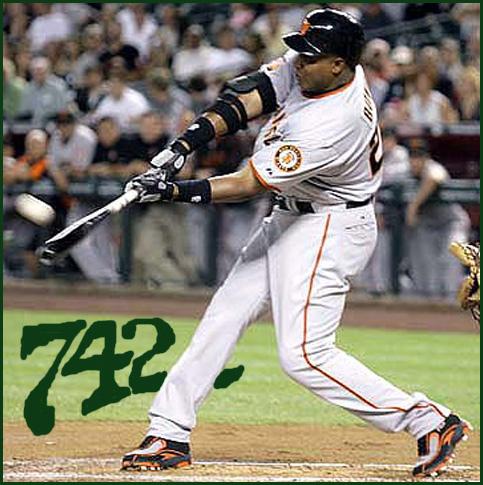Does he look like a professional player?
Give a very brief answer. Yes. What is his name?
Be succinct. Barry bonds. Did the batter hit the ball yet?
Write a very short answer. Yes. Does the number written on the grass match the player's Jersey?
Concise answer only. No. What is the number on the picture?
Write a very short answer. 742. What number is written on the picture?
Quick response, please. 742. Is this baseball player a left-handed or right-handed batter?
Quick response, please. Left. 